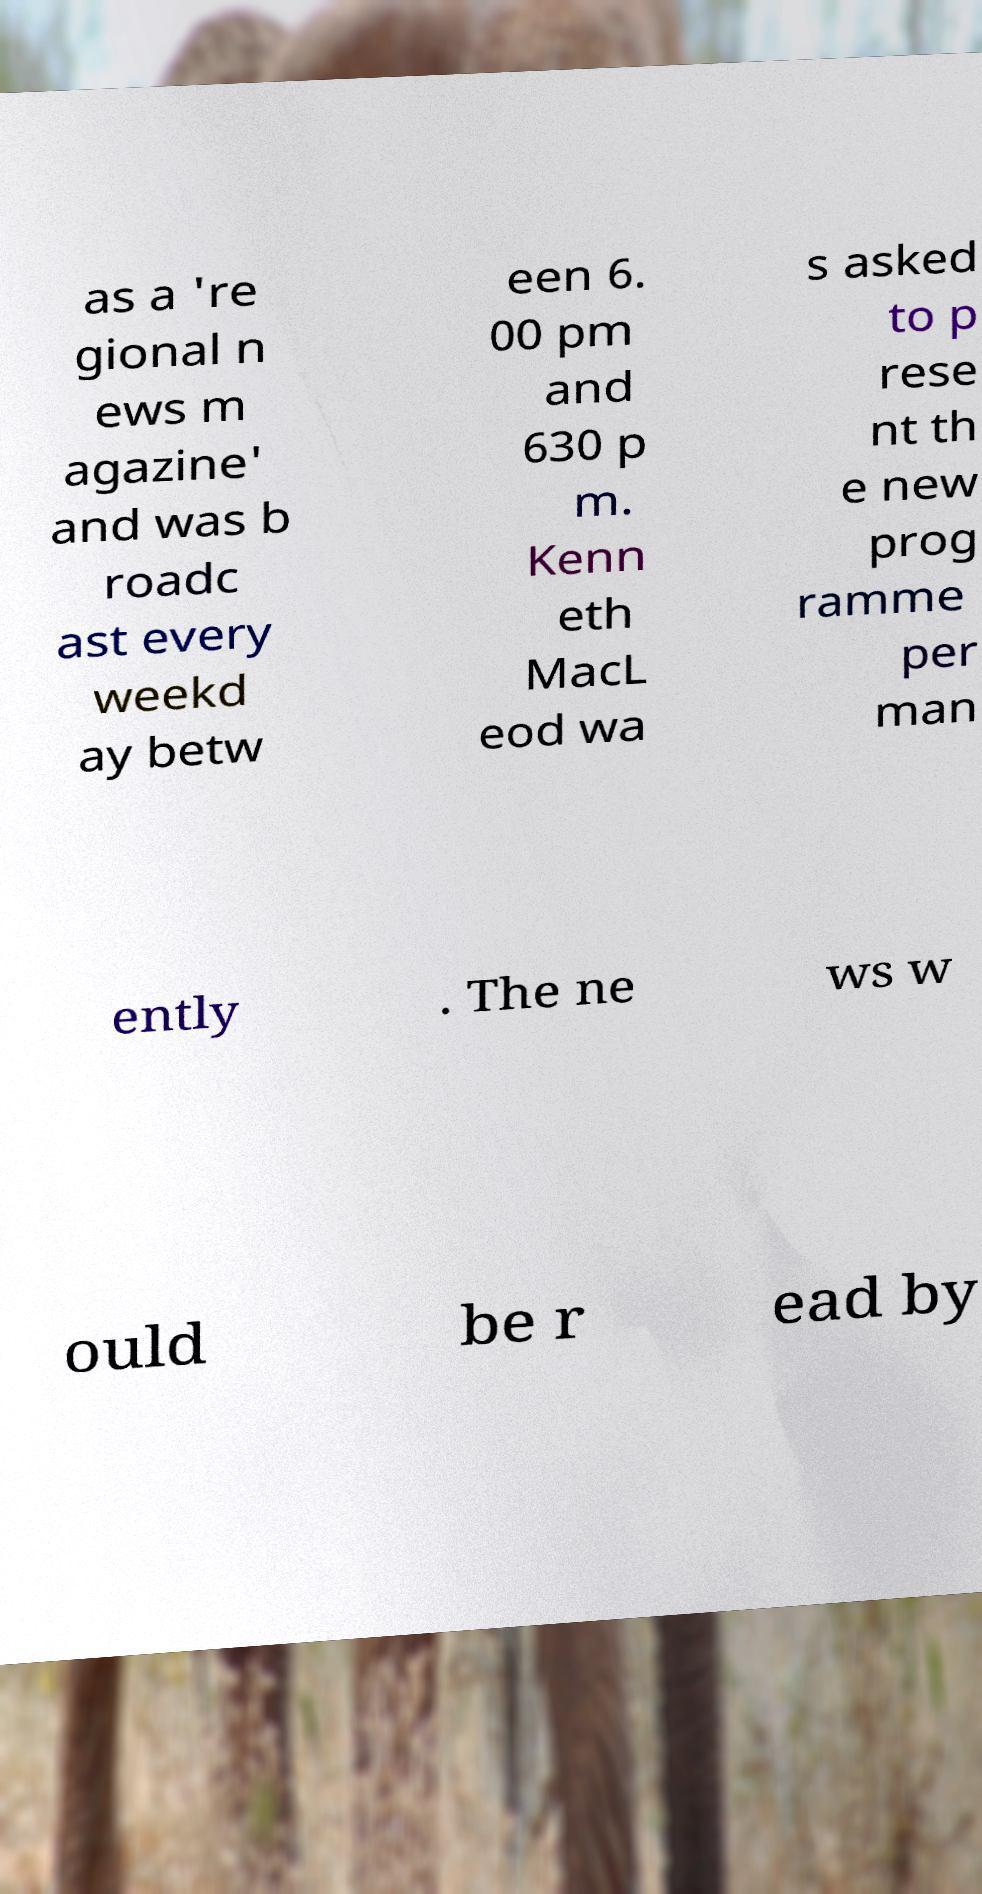There's text embedded in this image that I need extracted. Can you transcribe it verbatim? as a 're gional n ews m agazine' and was b roadc ast every weekd ay betw een 6. 00 pm and 630 p m. Kenn eth MacL eod wa s asked to p rese nt th e new prog ramme per man ently . The ne ws w ould be r ead by 